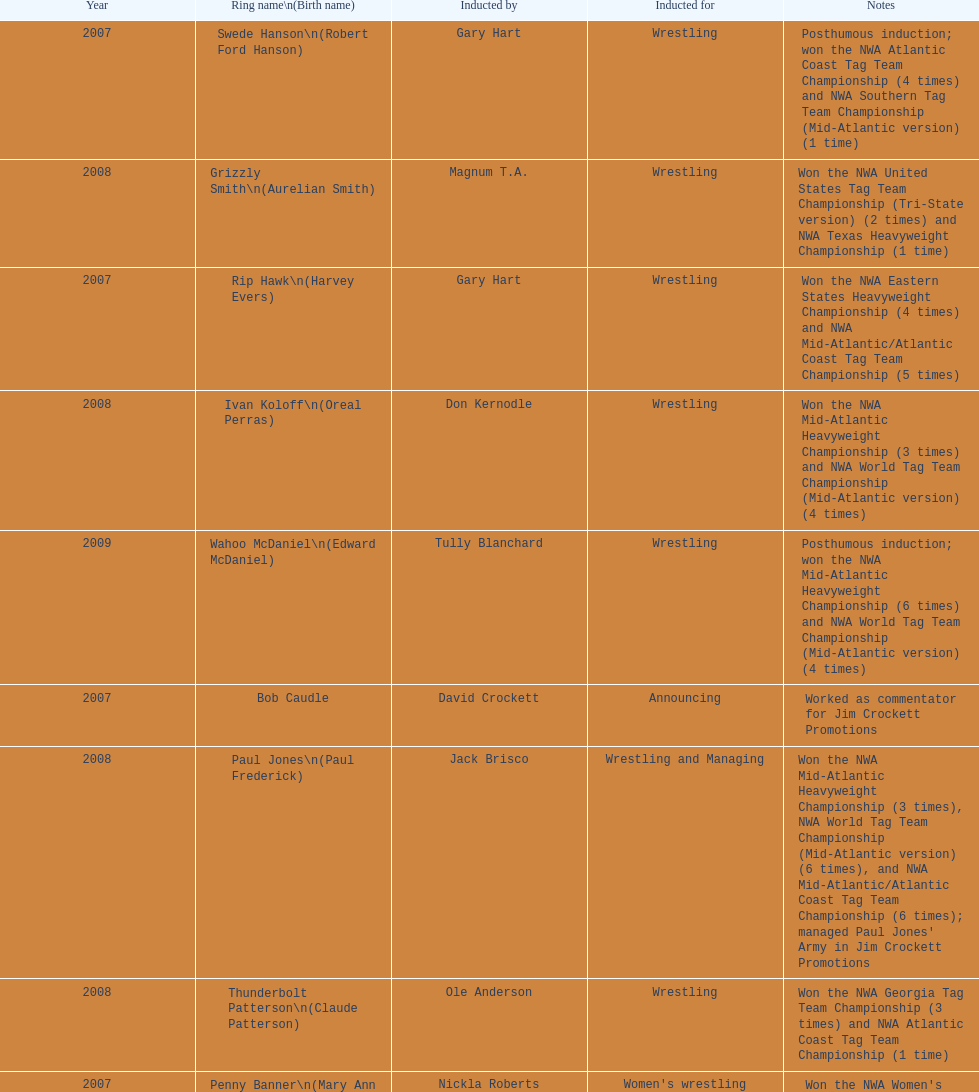How many members were brought in for announcing? 2. 